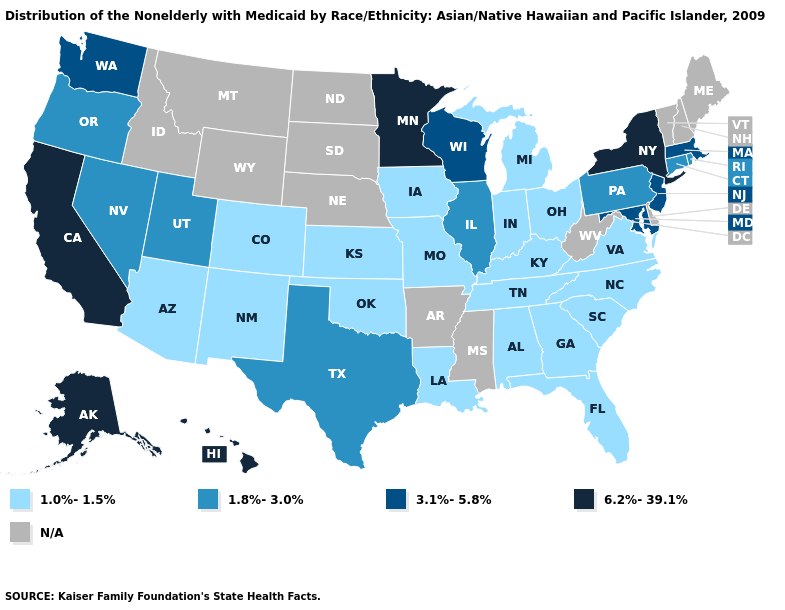What is the value of Virginia?
Keep it brief. 1.0%-1.5%. Name the states that have a value in the range N/A?
Keep it brief. Arkansas, Delaware, Idaho, Maine, Mississippi, Montana, Nebraska, New Hampshire, North Dakota, South Dakota, Vermont, West Virginia, Wyoming. Does Georgia have the highest value in the USA?
Short answer required. No. Does Nevada have the highest value in the West?
Concise answer only. No. Name the states that have a value in the range 1.8%-3.0%?
Write a very short answer. Connecticut, Illinois, Nevada, Oregon, Pennsylvania, Rhode Island, Texas, Utah. Name the states that have a value in the range 6.2%-39.1%?
Be succinct. Alaska, California, Hawaii, Minnesota, New York. Is the legend a continuous bar?
Be succinct. No. Which states hav the highest value in the MidWest?
Short answer required. Minnesota. Does New Mexico have the highest value in the USA?
Short answer required. No. What is the value of South Carolina?
Be succinct. 1.0%-1.5%. Does New York have the highest value in the USA?
Short answer required. Yes. Among the states that border Mississippi , which have the lowest value?
Write a very short answer. Alabama, Louisiana, Tennessee. What is the lowest value in states that border Louisiana?
Quick response, please. 1.8%-3.0%. Name the states that have a value in the range 1.8%-3.0%?
Write a very short answer. Connecticut, Illinois, Nevada, Oregon, Pennsylvania, Rhode Island, Texas, Utah. 